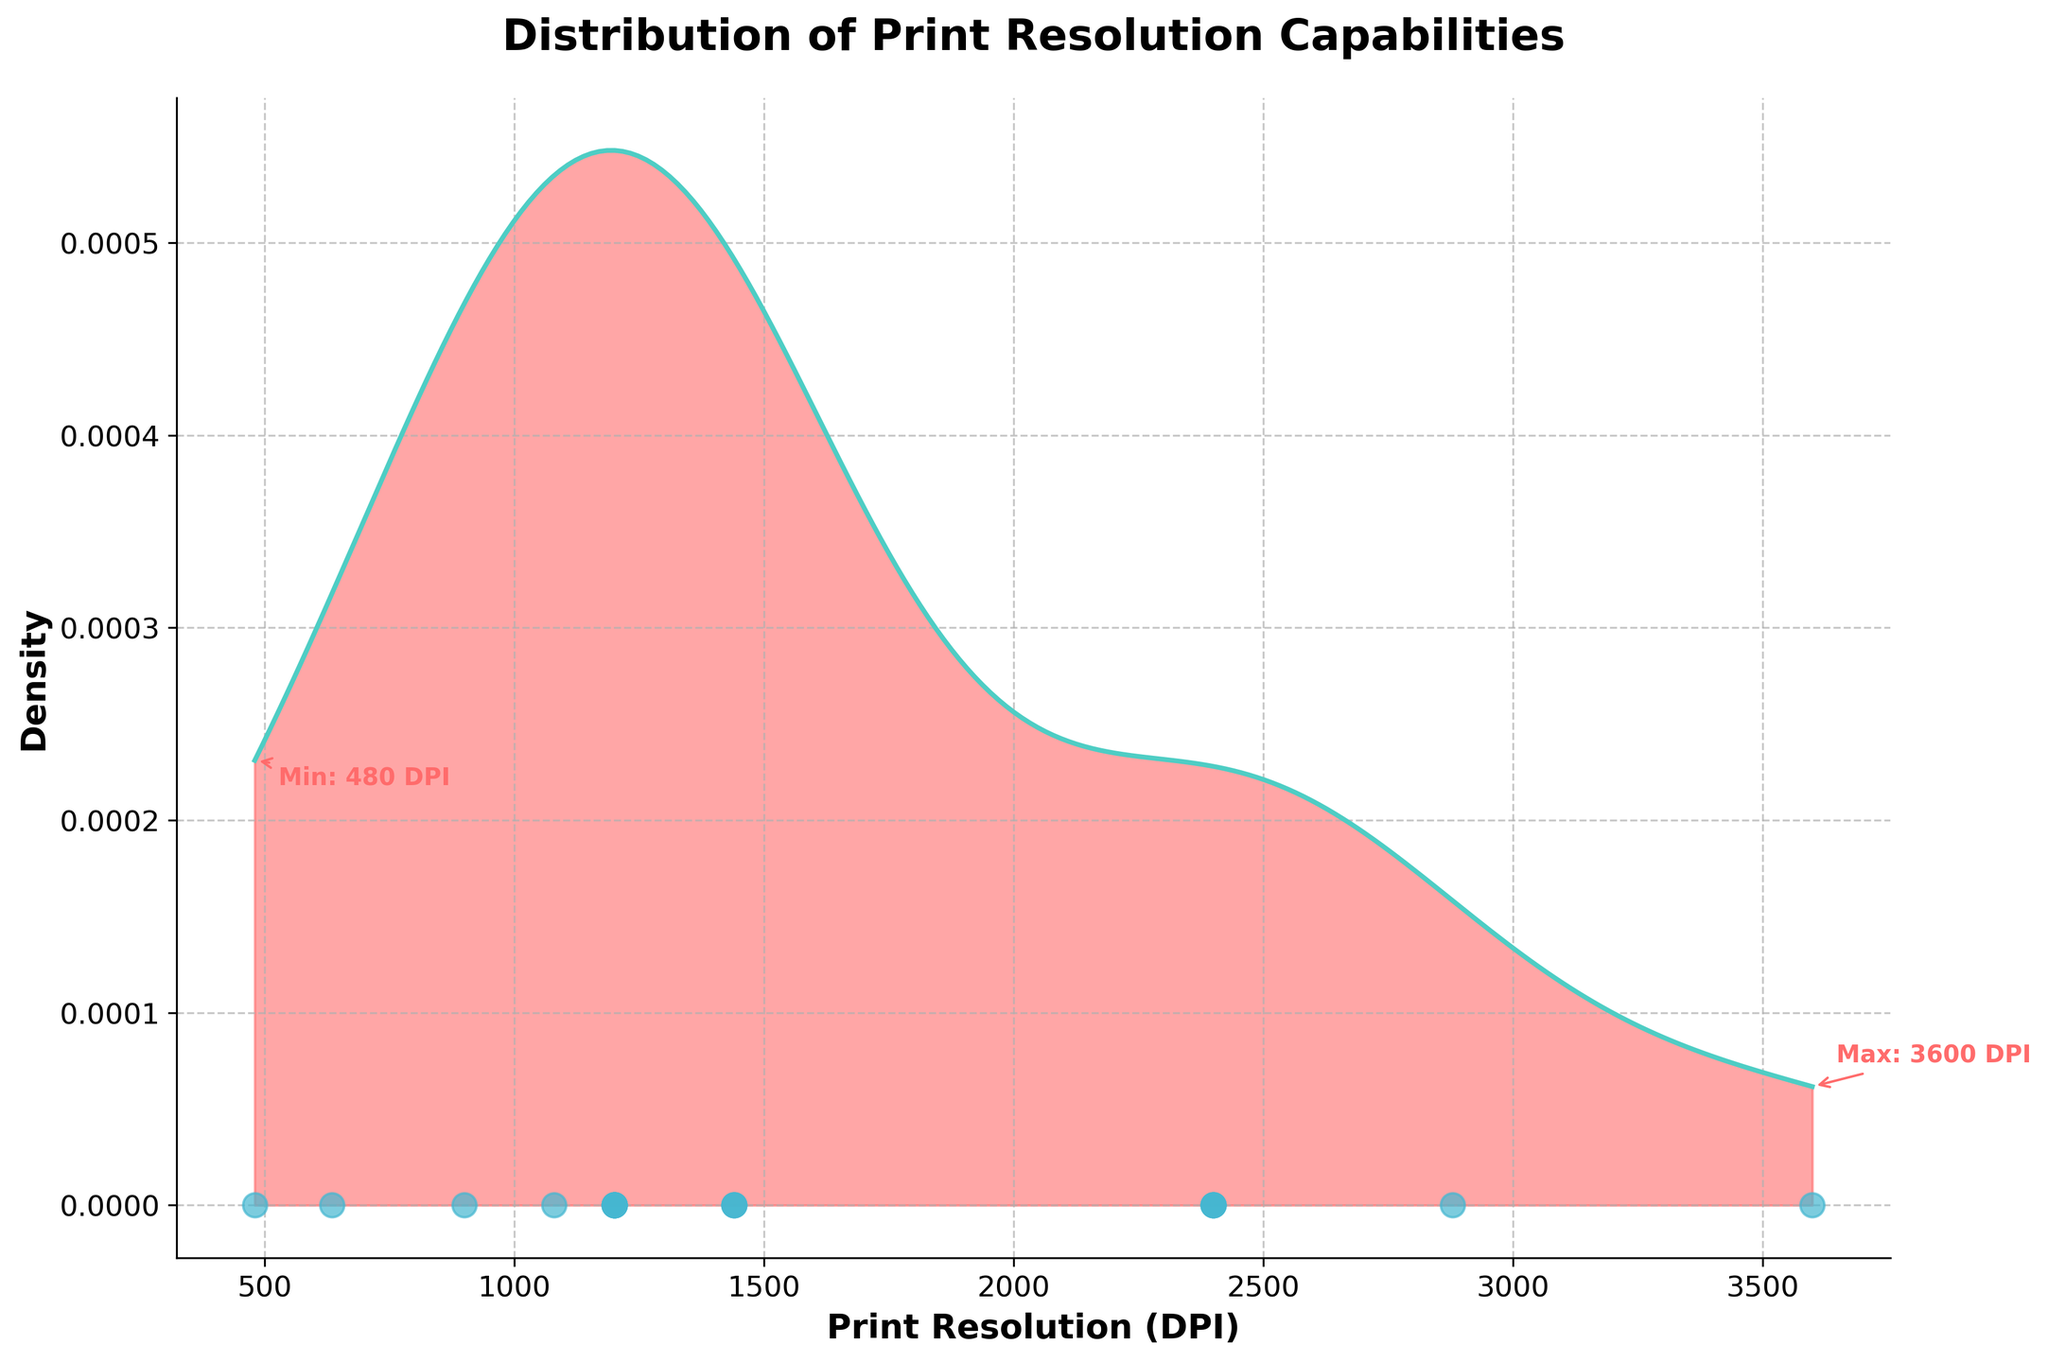What is the title of the plot? The title of the plot is at the top and clearly indicates what the plot is about.
Answer: Distribution of Print Resolution Capabilities What does the x-axis represent? The x-axis is labeled and indicates the measured variable.
Answer: Print Resolution (DPI) What color is used to fill the density area under the curve? The fill color can be seen covering the area under the density curve.
Answer: Light red Which printer model has the highest print resolution and what is that resolution? The plot has an annotation marking the maximum resolution, which points to the highest resolution value and indicates the printer model.
Answer: Konica Minolta AccurioPress C14000, 3600 DPI Which printer models share the common print resolution of 1200 DPI, and how many are there? Scatter points on the x-axis at 1200 DPI marker represent the printer models. Count the number of these points and refer to the data labels to identify the models.
Answer: Six models: HP Latex 800W, Fujifilm Acuity LED 1600 II, EFI VUTEk h5, OKI Pro9542, Brother GTXpro, Kornit Atlas MAX What is the lowest print resolution, and which printer model has it? Refer to the annotation that marks the minimum print resolution.
Answer: Mimaki TS55-1800, 480 DPI In which range are the majority of the print resolutions clustered? Observe the density curve and find where its peak is located and the range with the highest density.
Answer: Around 1200 - 2400 DPI How many distinct print resolution values are shown on the plot? Count the number of unique scatter points on the x-axis.
Answer: 10 distinct values Compare the density of print resolutions between 2400 DPI and 3600 DPI. Which range has higher density? Observe the height of the density curve between these two ranges.
Answer: 2400 DPI range has a higher density Are there more printer models with a print resolution greater than or less than 1500 DPI? Count the scatter points above and below the 1500 DPI marker.
Answer: Less than 1500 DPI What visual elements are used to highlight the data points on the plot? Identify the plot features used to represent the data points.
Answer: Scatter points 